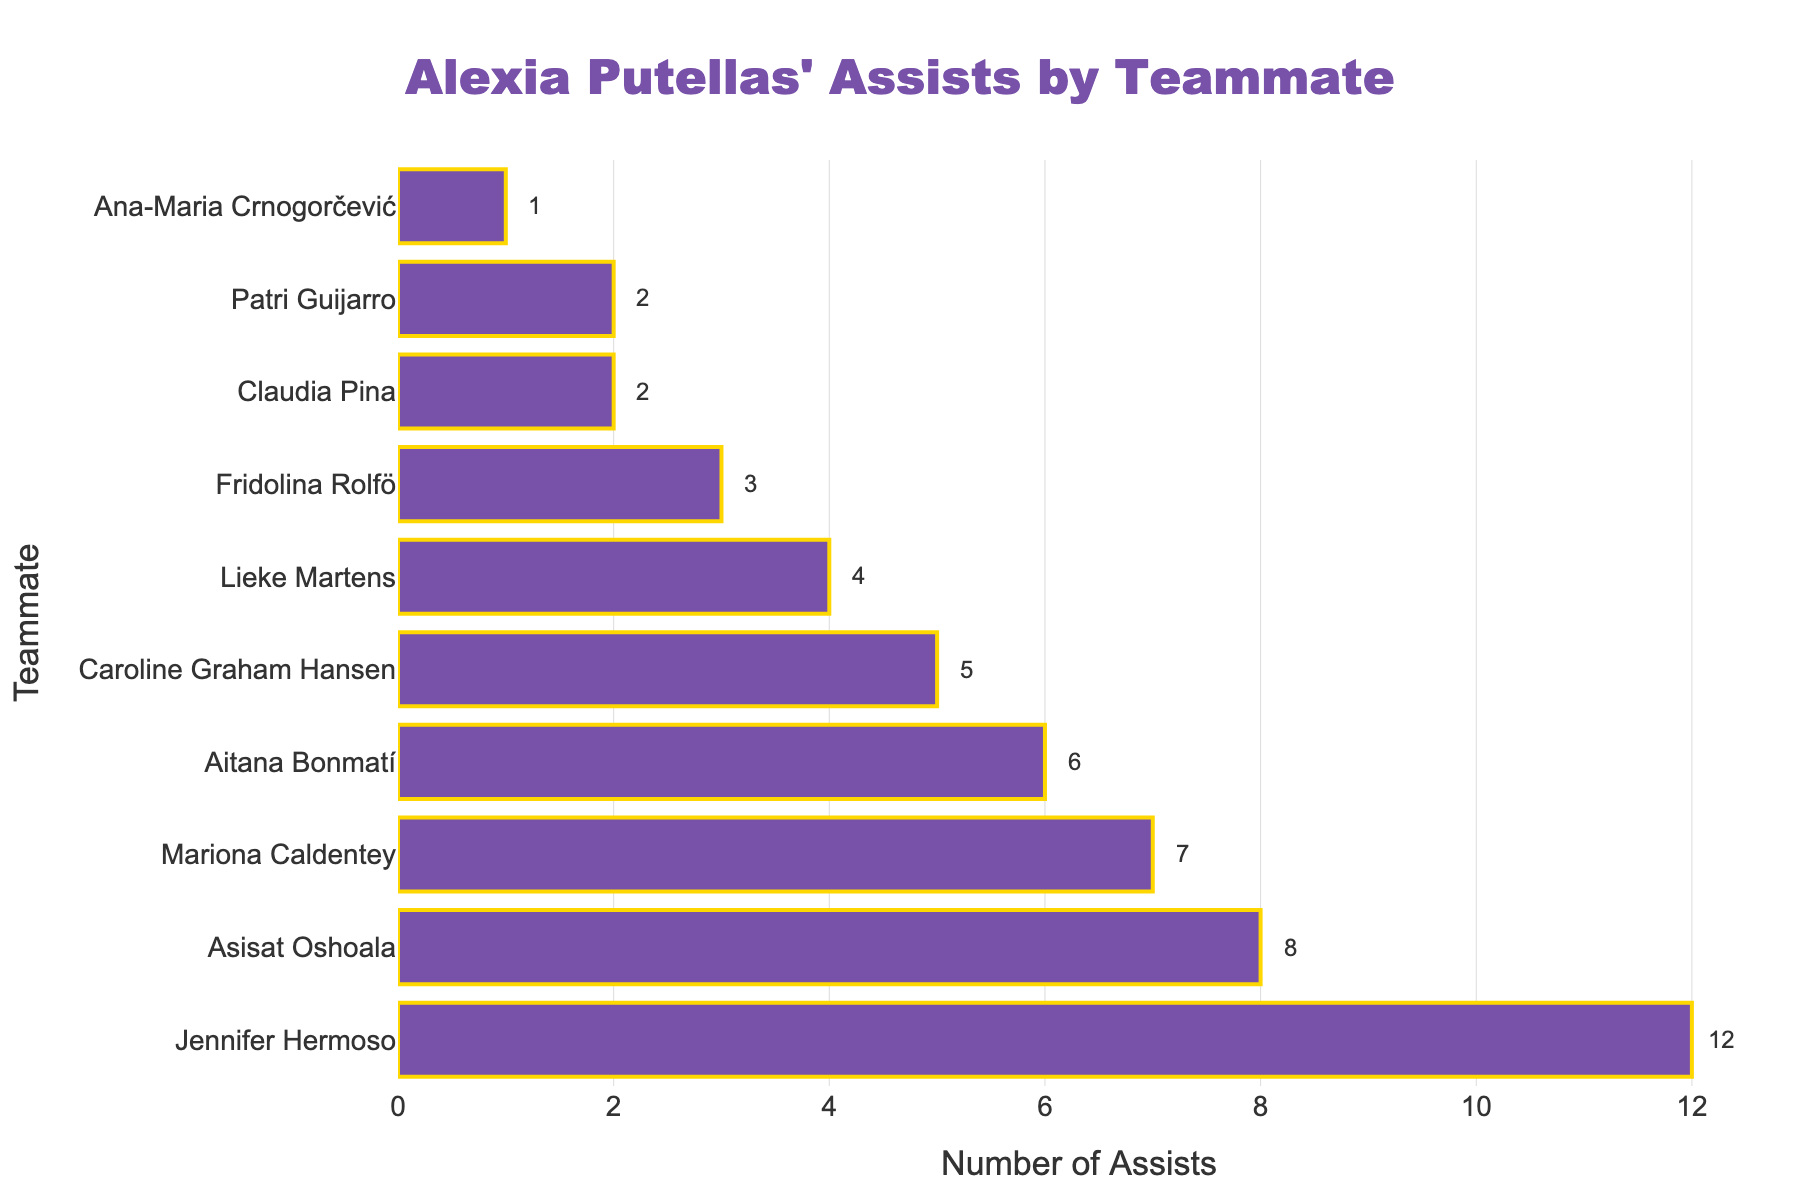Which teammate has received the most assists from Alexia Putellas? The bar chart shows the number of assists Alexia Putellas has made to each teammate, and the longest bar represents the highest number of assists. In this case, Jennifer Hermoso has the longest bar with 12 assists.
Answer: Jennifer Hermoso How many more assists did Alexia Putellas make to Jennifer Hermoso compared to Caroline Graham Hansen? To find the difference, look at the number of assists to each player: Jennifer Hermoso has 12 assists and Caroline Graham Hansen has 5. The difference is 12 - 5.
Answer: 7 Out of all the players, who received the least number of assists from Alexia Putellas? The bar chart shows each player's assists, and the smallest bar represents the least number of assists. Ana-Maria Crnogorčević has the smallest bar with 1 assist.
Answer: Ana-Maria Crnogorčević What is the total number of assists Alexia Putellas made to Mariona Caldentey and Aitana Bonmatí combined? Add the number of assists to each player: Mariona Caldentey has 7 assists and Aitana Bonmatí has 6. The total is 7 + 6.
Answer: 13 Compare the assists given by Alexia Putellas to Aitana Bonmatí and Lieke Martens. How many more did she give to Aitana Bonmatí? Aitana Bonmatí received 6 assists and Lieke Martens received 4 assists from Alexia Putellas. The difference is 6 - 4.
Answer: 2 What is the average number of assists given to all teammates listed in the chart? First, sum the total number of assists: 12 + 8 + 7 + 6 + 5 + 4 + 3 + 2 + 2 + 1 = 50 assists. Then, divide by the number of players (10): 50 / 10.
Answer: 5 How many assists did Alexia Putellas make to teammates who received fewer assists than Asisat Oshoala? Players who received fewer assists than Asisat Oshoala (8) are Mariona Caldentey (7), Aitana Bonmatí (6), Caroline Graham Hansen (5), Lieke Martens (4), Fridolina Rolfö (3), Claudia Pina (2), Patri Guijarro (2), and Ana-Maria Crnogorčević (1). Sum these values: 7 + 6 + 5 + 4 + 3 + 2 + 2 + 1 = 30.
Answer: 30 How many players received more than 5 assists from Alexia Putellas? Count the number of players whose bars are larger than 5 assists: Jennifer Hermoso (12), Asisat Oshoala (8), Mariona Caldentey (7), Aitana Bonmatí (6). There are 4 players.
Answer: 4 What percentage of Alexia Putellas' total assists were made to the top two teammates in the chart? First, determine the total number of assists to the top two teammates: Jennifer Hermoso (12) and Asisat Oshoala (8), totaling 20. The overall total number of assists is 50. Calculate the percentage: (20 / 50) * 100 = 40%.
Answer: 40% By how much do the assists made to Claudia Pina and Patri Guijarro combined fall short of the assists made to Asisat Oshoala? Claudia Pina and Patri Guijarro have 2 assists each, summing to 4. Asisat Oshoala has 8 assists. The difference is 8 - 4.
Answer: 4 